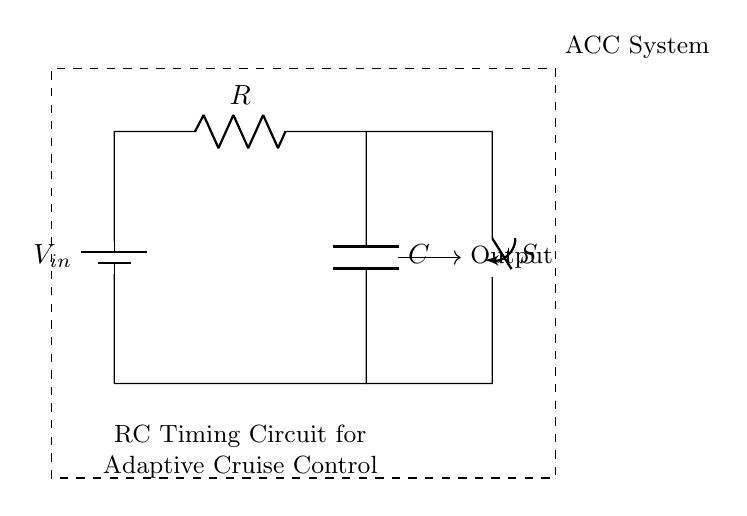What are the main components in this circuit? The circuit consists of a battery, a resistor, a capacitor, and a switch. The battery provides the voltage, while the resistor and capacitor form the timing element, and the switch controls the connection.
Answer: battery, resistor, capacitor, switch What does the output represent in this circuit? The output represents the voltage across the capacitor, which changes over time based on the charging and discharging cycles determined by the resistor-capacitor combination.
Answer: voltage across capacitor What is the purpose of the switch in this RC timing circuit? The switch is used to connect or disconnect the capacitor from the circuit, allowing control over when the capacitor charges and discharges, thereby affecting the timing behavior.
Answer: control timing How does the resistor affect the charging time of the capacitor? The resistor affects the time constant of the circuit, which is the product of resistance and capacitance (RC). A higher resistance will increase the charging time, and a lower resistance will decrease it.
Answer: increases time constant What is the time constant of the circuit if R is 10k ohms and C is 100 microfarads? The time constant is calculated by multiplying the resistance (in ohms) by the capacitance (in farads). Here, 10,000 ohms times 0.0001 farads gives 1 second.
Answer: 1 second What type of system is this circuit designed for? This circuit is designed for an adaptive cruise control system, which adjusts the vehicle's speed based on distance to other vehicles.
Answer: adaptive cruise control 